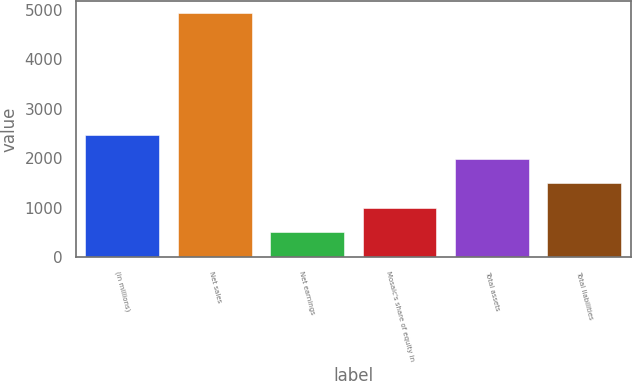Convert chart to OTSL. <chart><loc_0><loc_0><loc_500><loc_500><bar_chart><fcel>(in millions)<fcel>Net sales<fcel>Net earnings<fcel>Mosaic's share of equity in<fcel>Total assets<fcel>Total liabilities<nl><fcel>2475.85<fcel>4938.4<fcel>505.81<fcel>998.32<fcel>1983.34<fcel>1490.83<nl></chart> 